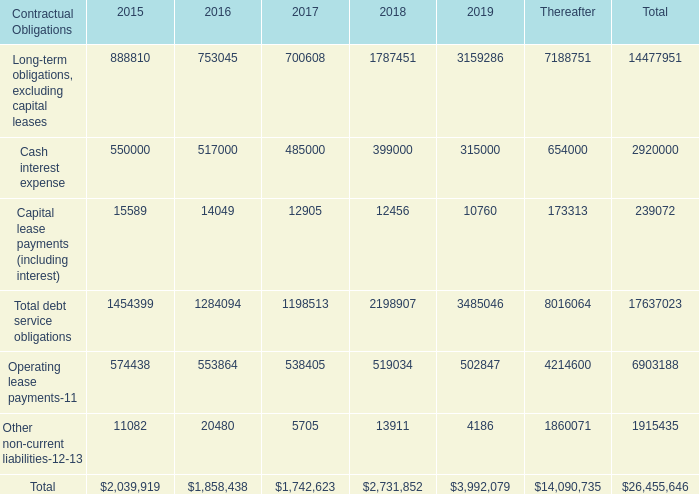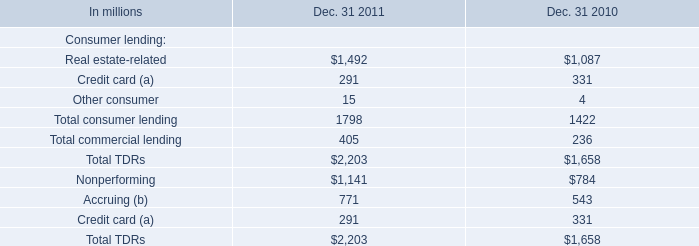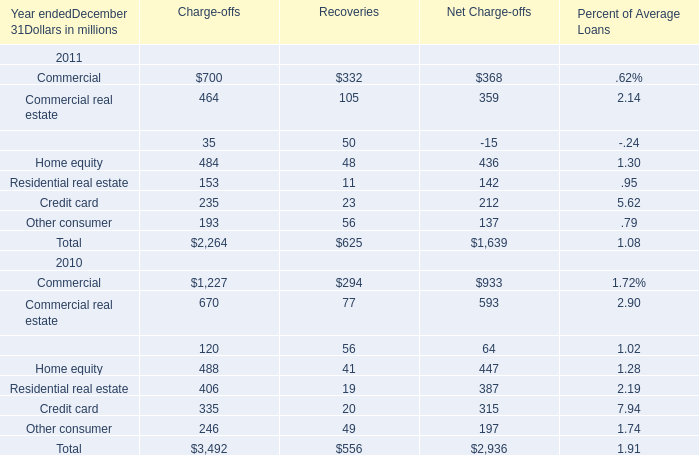How many elements' value in 2011 are lower than the previous year (for recoveries)? 
Answer: 1:Residential real estate. 